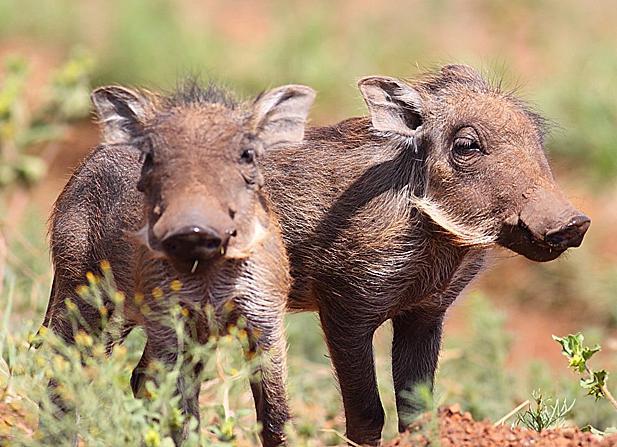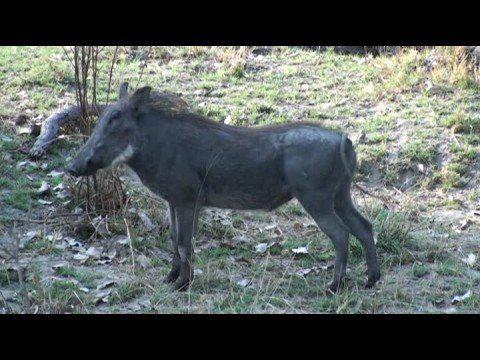The first image is the image on the left, the second image is the image on the right. Given the left and right images, does the statement "The right image contains twice as many warthogs as the left image, and all warthogs are turned forward instead of in profile or backward." hold true? Answer yes or no. No. The first image is the image on the left, the second image is the image on the right. For the images shown, is this caption "There is exactly two warthogs in the left image." true? Answer yes or no. Yes. 